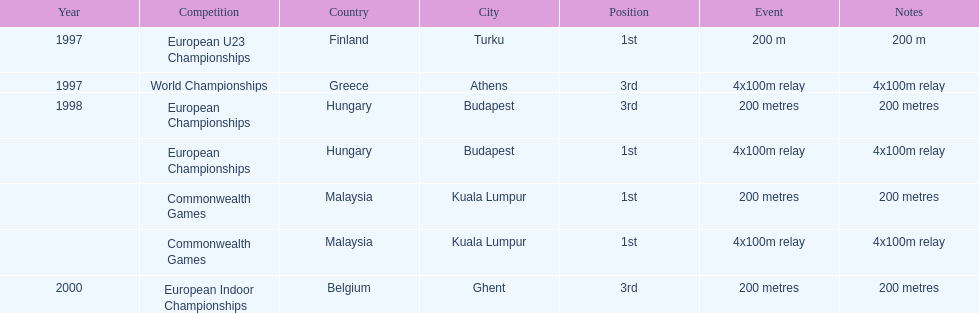List the competitions that have the same relay as world championships from athens, greece. European Championships, Commonwealth Games. 